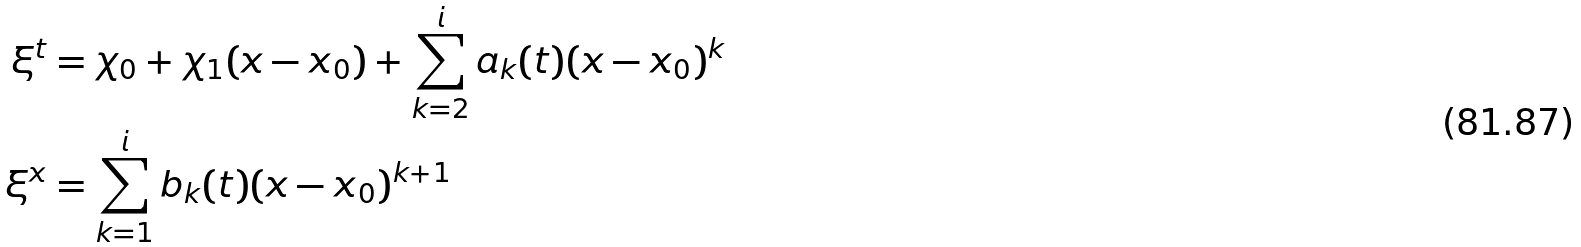<formula> <loc_0><loc_0><loc_500><loc_500>\xi ^ { t } & = \chi _ { 0 } + \chi _ { 1 } ( x - x _ { 0 } ) + \sum _ { k = 2 } ^ { \i i } a _ { k } ( t ) ( x - x _ { 0 } ) ^ { k } \\ \xi ^ { x } & = \sum _ { k = 1 } ^ { \i i } b _ { k } ( t ) ( x - x _ { 0 } ) ^ { k + 1 }</formula> 